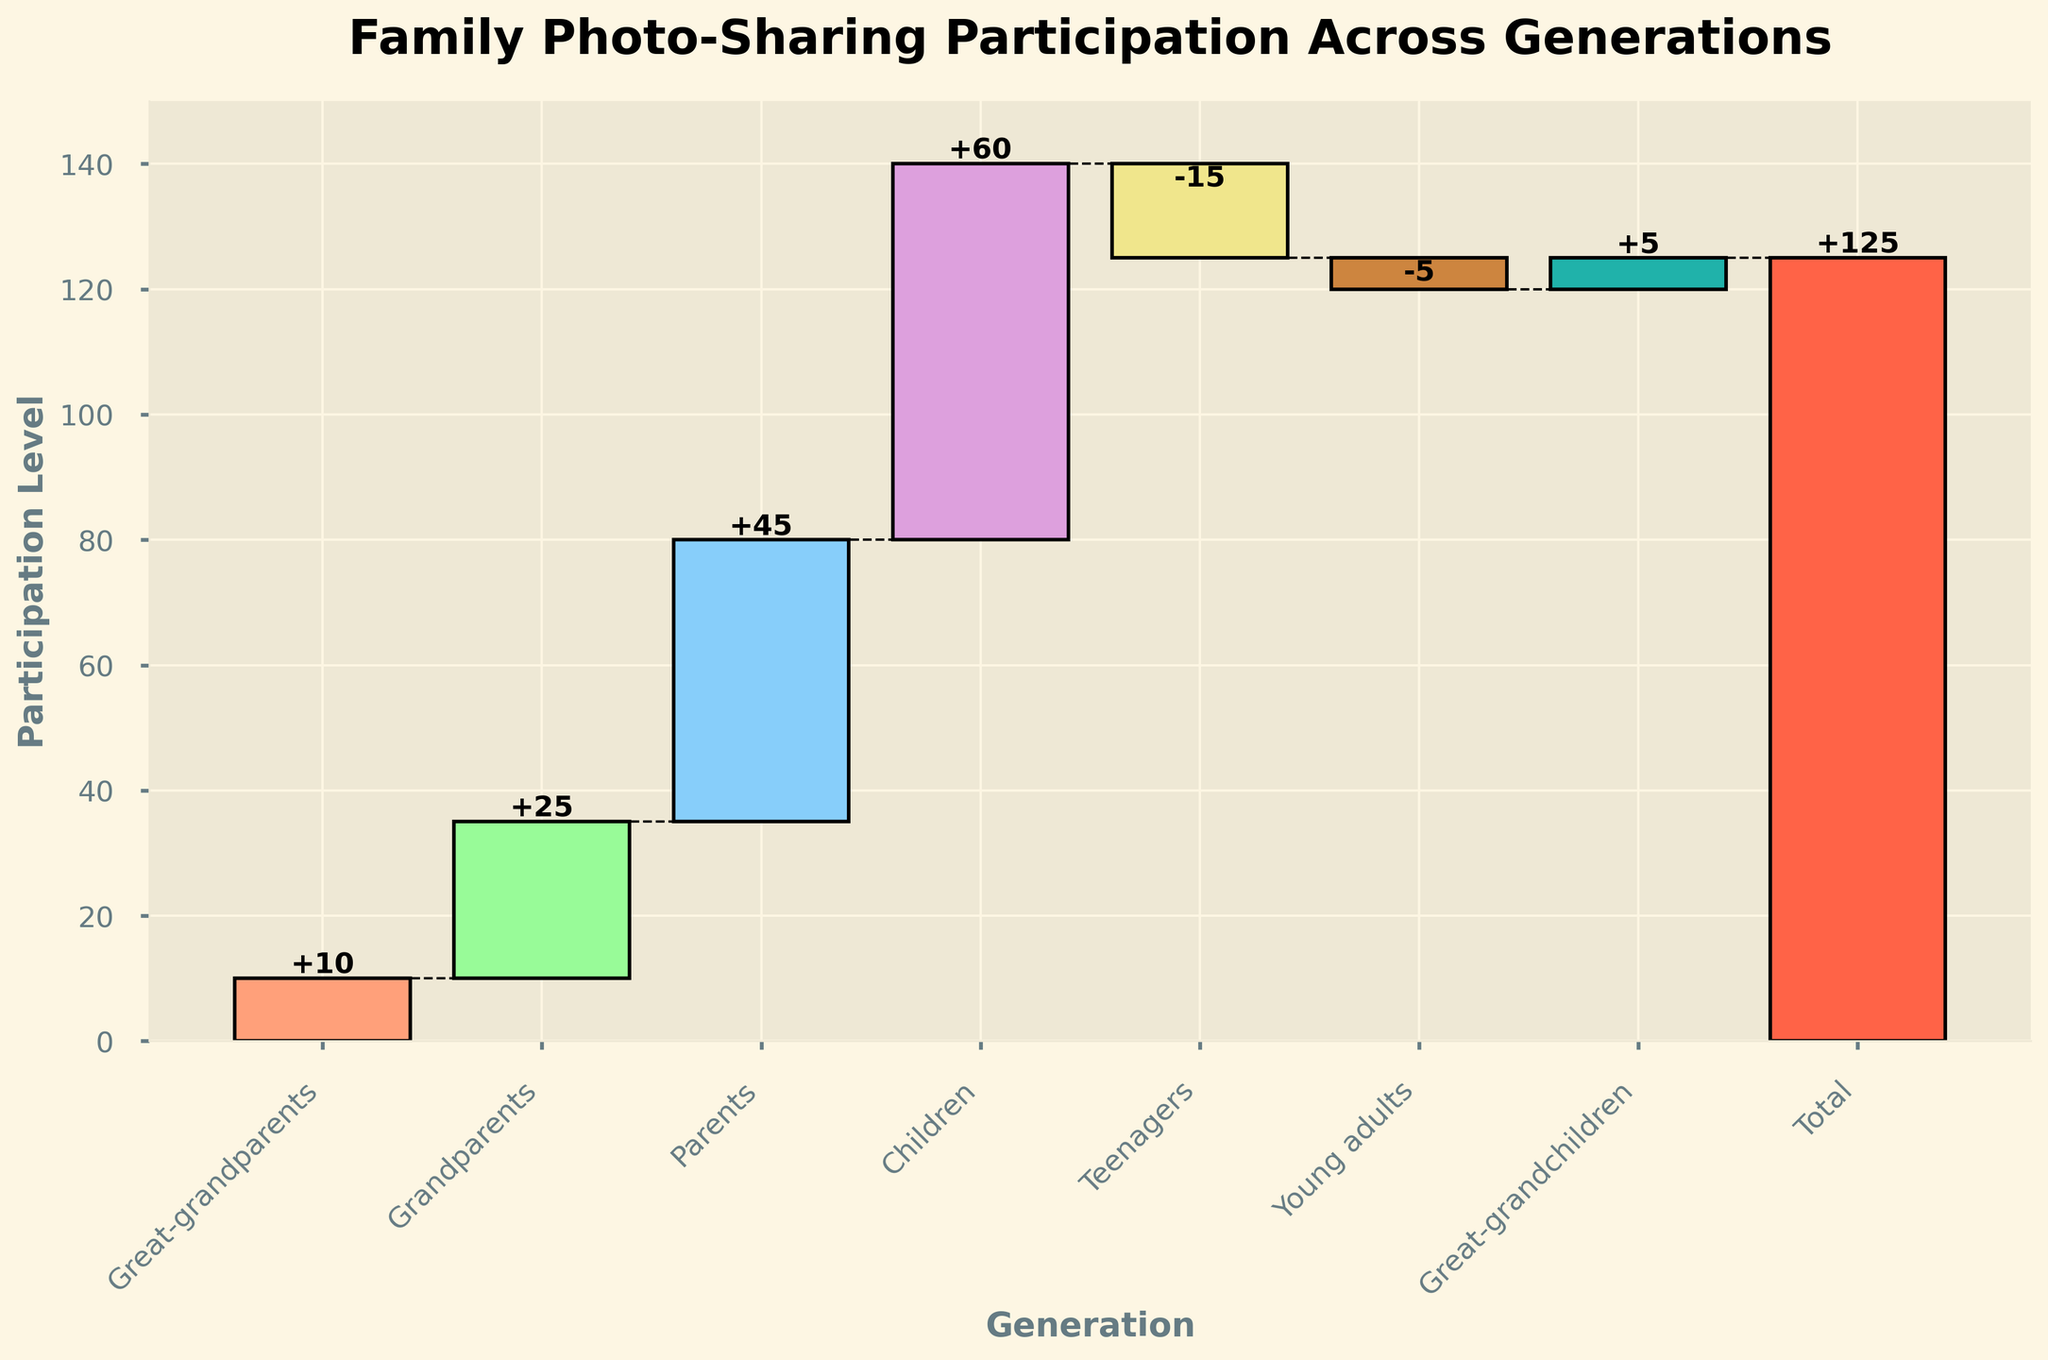What's the title of the chart? The title is located at the top of the chart and typically describes the main topic of the dataset. Here, the title is "Family Photo-Sharing Participation Across Generations."
Answer: Family Photo-Sharing Participation Across Generations What's the value associated with Great-grandparents? The bar for Great-grandparents is the first bar on the left side of the chart. The value indicated on the chart is 10.
Answer: 10 How many generational categories are displayed in the chart? The chart displays individual bars representing different generational categories, from Great-grandparents to Great-grandchildren, including a Total bar. There are 7 generational categories, plus the Total.
Answer: 8 Which generational group has the highest increase in participation? By looking at the height of the bars representing the positive values, the group with the tallest bar is Children with a value of 60.
Answer: Children How much did participation decrease from Teenagers? The value associated with Teenagers is marked with a negative number, specifically -15.
Answer: 15 Calculate the cumulative increase in participation from Great-grandparents to Children. Adding the values for Great-grandparents (10), Grandparents (25), Parents (45), and Children (60) gives a cumulative increase: 10+25+45+60 = 140.
Answer: 140 What's the total participation value displayed in the chart? The bar labeled "Total" at the end of the chart displays the overall total participation value, which is 125.
Answer: 125 Compare the participation level of Great-grandparents and Young adults. The value for Great-grandparents is 10, and the value for Young adults is -5. Since 10 is greater than -5, Great-grandparents have a higher participation level than Young adults.
Answer: Great-grandparents What is the difference in participation between Parents and Teenagers? The value for Parents is 45 and for Teenagers is -15. The difference can be calculated as 45 - (-15) = 45 + 15 = 60.
Answer: 60 Explain why the participation level of Teenagers is represented differently than that of Parents. Teenagers have a negative value (-15) which represents a decrease, while Parents have a positive value (45), indicating an increase. Negative values are typically shown below the baseline in waterfall charts.
Answer: Teenagers show a decrease 